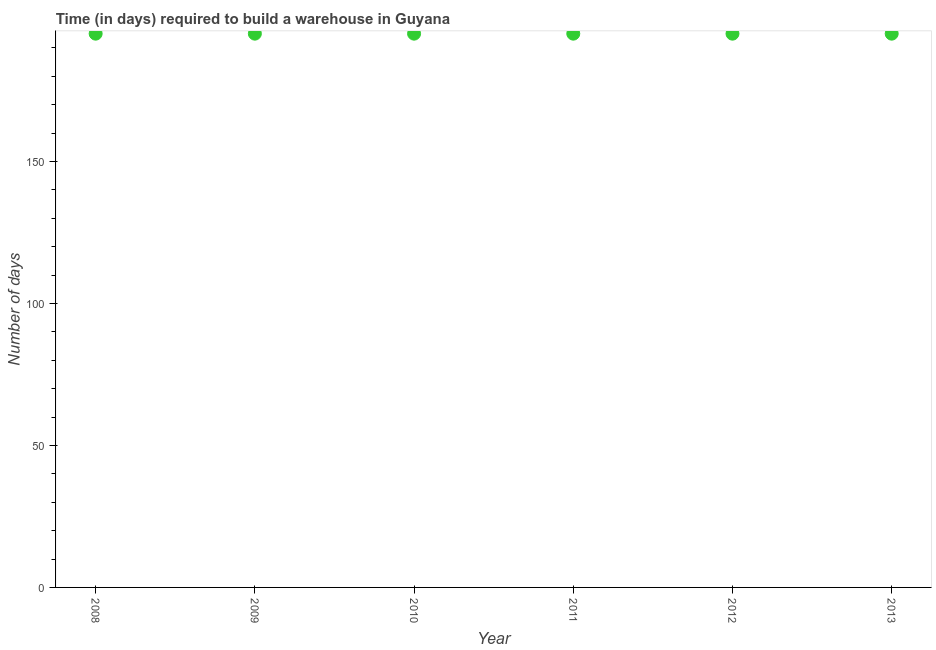What is the time required to build a warehouse in 2011?
Your answer should be compact. 195. Across all years, what is the maximum time required to build a warehouse?
Offer a very short reply. 195. Across all years, what is the minimum time required to build a warehouse?
Offer a terse response. 195. In which year was the time required to build a warehouse maximum?
Ensure brevity in your answer.  2008. In which year was the time required to build a warehouse minimum?
Your response must be concise. 2008. What is the sum of the time required to build a warehouse?
Offer a terse response. 1170. What is the difference between the time required to build a warehouse in 2011 and 2012?
Make the answer very short. 0. What is the average time required to build a warehouse per year?
Provide a short and direct response. 195. What is the median time required to build a warehouse?
Keep it short and to the point. 195. Do a majority of the years between 2012 and 2013 (inclusive) have time required to build a warehouse greater than 30 days?
Ensure brevity in your answer.  Yes. What is the ratio of the time required to build a warehouse in 2009 to that in 2012?
Ensure brevity in your answer.  1. Is the difference between the time required to build a warehouse in 2008 and 2012 greater than the difference between any two years?
Offer a terse response. Yes. What is the difference between the highest and the lowest time required to build a warehouse?
Your response must be concise. 0. Does the time required to build a warehouse monotonically increase over the years?
Provide a short and direct response. No. What is the difference between two consecutive major ticks on the Y-axis?
Your answer should be compact. 50. Does the graph contain any zero values?
Your response must be concise. No. What is the title of the graph?
Keep it short and to the point. Time (in days) required to build a warehouse in Guyana. What is the label or title of the X-axis?
Give a very brief answer. Year. What is the label or title of the Y-axis?
Your response must be concise. Number of days. What is the Number of days in 2008?
Ensure brevity in your answer.  195. What is the Number of days in 2009?
Offer a very short reply. 195. What is the Number of days in 2010?
Make the answer very short. 195. What is the Number of days in 2011?
Offer a terse response. 195. What is the Number of days in 2012?
Offer a very short reply. 195. What is the Number of days in 2013?
Make the answer very short. 195. What is the difference between the Number of days in 2008 and 2009?
Your answer should be compact. 0. What is the difference between the Number of days in 2008 and 2010?
Offer a very short reply. 0. What is the difference between the Number of days in 2008 and 2011?
Ensure brevity in your answer.  0. What is the difference between the Number of days in 2008 and 2013?
Provide a short and direct response. 0. What is the difference between the Number of days in 2009 and 2012?
Offer a very short reply. 0. What is the difference between the Number of days in 2010 and 2011?
Provide a short and direct response. 0. What is the difference between the Number of days in 2011 and 2012?
Your answer should be very brief. 0. What is the ratio of the Number of days in 2008 to that in 2009?
Your answer should be compact. 1. What is the ratio of the Number of days in 2008 to that in 2011?
Offer a terse response. 1. What is the ratio of the Number of days in 2009 to that in 2011?
Your response must be concise. 1. What is the ratio of the Number of days in 2009 to that in 2012?
Provide a short and direct response. 1. What is the ratio of the Number of days in 2009 to that in 2013?
Provide a short and direct response. 1. What is the ratio of the Number of days in 2010 to that in 2012?
Provide a short and direct response. 1. What is the ratio of the Number of days in 2010 to that in 2013?
Your response must be concise. 1. What is the ratio of the Number of days in 2011 to that in 2013?
Provide a short and direct response. 1. 